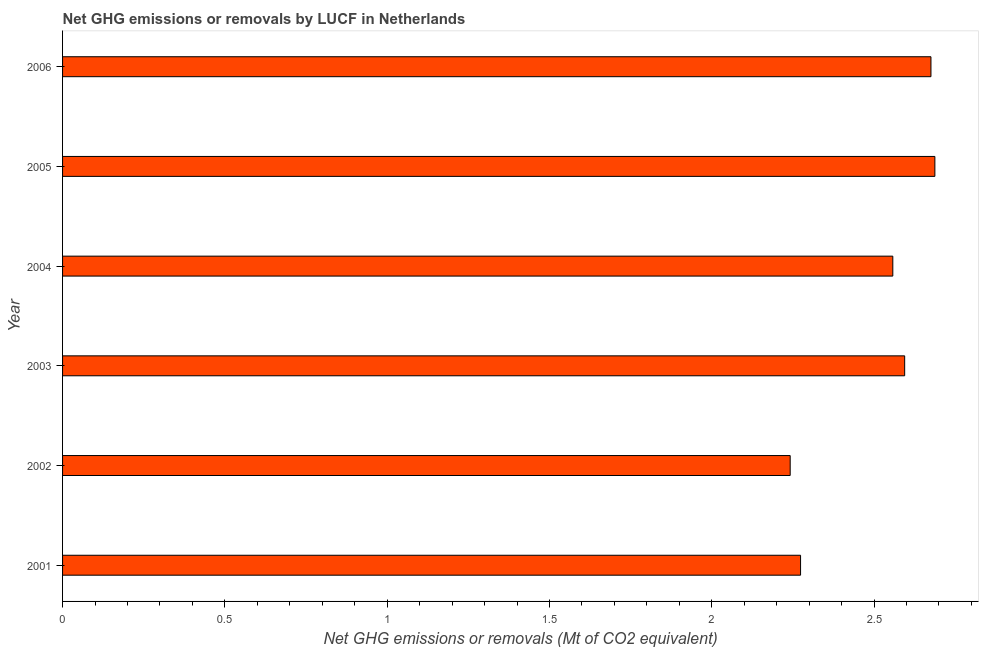What is the title of the graph?
Make the answer very short. Net GHG emissions or removals by LUCF in Netherlands. What is the label or title of the X-axis?
Keep it short and to the point. Net GHG emissions or removals (Mt of CO2 equivalent). What is the label or title of the Y-axis?
Provide a short and direct response. Year. What is the ghg net emissions or removals in 2003?
Your answer should be compact. 2.59. Across all years, what is the maximum ghg net emissions or removals?
Give a very brief answer. 2.69. Across all years, what is the minimum ghg net emissions or removals?
Your response must be concise. 2.24. What is the sum of the ghg net emissions or removals?
Ensure brevity in your answer.  15.03. What is the difference between the ghg net emissions or removals in 2004 and 2005?
Provide a short and direct response. -0.13. What is the average ghg net emissions or removals per year?
Provide a short and direct response. 2.5. What is the median ghg net emissions or removals?
Offer a very short reply. 2.58. In how many years, is the ghg net emissions or removals greater than 1.8 Mt?
Make the answer very short. 6. What is the ratio of the ghg net emissions or removals in 2002 to that in 2003?
Provide a short and direct response. 0.86. What is the difference between the highest and the second highest ghg net emissions or removals?
Keep it short and to the point. 0.01. What is the difference between the highest and the lowest ghg net emissions or removals?
Provide a short and direct response. 0.45. Are all the bars in the graph horizontal?
Offer a very short reply. Yes. How many years are there in the graph?
Your answer should be compact. 6. What is the difference between two consecutive major ticks on the X-axis?
Your answer should be compact. 0.5. What is the Net GHG emissions or removals (Mt of CO2 equivalent) of 2001?
Provide a short and direct response. 2.27. What is the Net GHG emissions or removals (Mt of CO2 equivalent) in 2002?
Your answer should be compact. 2.24. What is the Net GHG emissions or removals (Mt of CO2 equivalent) in 2003?
Make the answer very short. 2.59. What is the Net GHG emissions or removals (Mt of CO2 equivalent) of 2004?
Offer a terse response. 2.56. What is the Net GHG emissions or removals (Mt of CO2 equivalent) of 2005?
Give a very brief answer. 2.69. What is the Net GHG emissions or removals (Mt of CO2 equivalent) in 2006?
Give a very brief answer. 2.68. What is the difference between the Net GHG emissions or removals (Mt of CO2 equivalent) in 2001 and 2002?
Provide a short and direct response. 0.03. What is the difference between the Net GHG emissions or removals (Mt of CO2 equivalent) in 2001 and 2003?
Offer a terse response. -0.32. What is the difference between the Net GHG emissions or removals (Mt of CO2 equivalent) in 2001 and 2004?
Ensure brevity in your answer.  -0.28. What is the difference between the Net GHG emissions or removals (Mt of CO2 equivalent) in 2001 and 2005?
Your answer should be compact. -0.41. What is the difference between the Net GHG emissions or removals (Mt of CO2 equivalent) in 2001 and 2006?
Keep it short and to the point. -0.4. What is the difference between the Net GHG emissions or removals (Mt of CO2 equivalent) in 2002 and 2003?
Keep it short and to the point. -0.35. What is the difference between the Net GHG emissions or removals (Mt of CO2 equivalent) in 2002 and 2004?
Give a very brief answer. -0.32. What is the difference between the Net GHG emissions or removals (Mt of CO2 equivalent) in 2002 and 2005?
Ensure brevity in your answer.  -0.45. What is the difference between the Net GHG emissions or removals (Mt of CO2 equivalent) in 2002 and 2006?
Keep it short and to the point. -0.43. What is the difference between the Net GHG emissions or removals (Mt of CO2 equivalent) in 2003 and 2004?
Keep it short and to the point. 0.04. What is the difference between the Net GHG emissions or removals (Mt of CO2 equivalent) in 2003 and 2005?
Offer a terse response. -0.09. What is the difference between the Net GHG emissions or removals (Mt of CO2 equivalent) in 2003 and 2006?
Provide a succinct answer. -0.08. What is the difference between the Net GHG emissions or removals (Mt of CO2 equivalent) in 2004 and 2005?
Provide a short and direct response. -0.13. What is the difference between the Net GHG emissions or removals (Mt of CO2 equivalent) in 2004 and 2006?
Keep it short and to the point. -0.12. What is the difference between the Net GHG emissions or removals (Mt of CO2 equivalent) in 2005 and 2006?
Provide a succinct answer. 0.01. What is the ratio of the Net GHG emissions or removals (Mt of CO2 equivalent) in 2001 to that in 2002?
Keep it short and to the point. 1.01. What is the ratio of the Net GHG emissions or removals (Mt of CO2 equivalent) in 2001 to that in 2003?
Your answer should be compact. 0.88. What is the ratio of the Net GHG emissions or removals (Mt of CO2 equivalent) in 2001 to that in 2004?
Give a very brief answer. 0.89. What is the ratio of the Net GHG emissions or removals (Mt of CO2 equivalent) in 2001 to that in 2005?
Offer a very short reply. 0.85. What is the ratio of the Net GHG emissions or removals (Mt of CO2 equivalent) in 2002 to that in 2003?
Make the answer very short. 0.86. What is the ratio of the Net GHG emissions or removals (Mt of CO2 equivalent) in 2002 to that in 2004?
Give a very brief answer. 0.88. What is the ratio of the Net GHG emissions or removals (Mt of CO2 equivalent) in 2002 to that in 2005?
Your answer should be very brief. 0.83. What is the ratio of the Net GHG emissions or removals (Mt of CO2 equivalent) in 2002 to that in 2006?
Give a very brief answer. 0.84. What is the ratio of the Net GHG emissions or removals (Mt of CO2 equivalent) in 2003 to that in 2005?
Keep it short and to the point. 0.96. What is the ratio of the Net GHG emissions or removals (Mt of CO2 equivalent) in 2004 to that in 2005?
Provide a short and direct response. 0.95. What is the ratio of the Net GHG emissions or removals (Mt of CO2 equivalent) in 2004 to that in 2006?
Make the answer very short. 0.96. What is the ratio of the Net GHG emissions or removals (Mt of CO2 equivalent) in 2005 to that in 2006?
Make the answer very short. 1. 